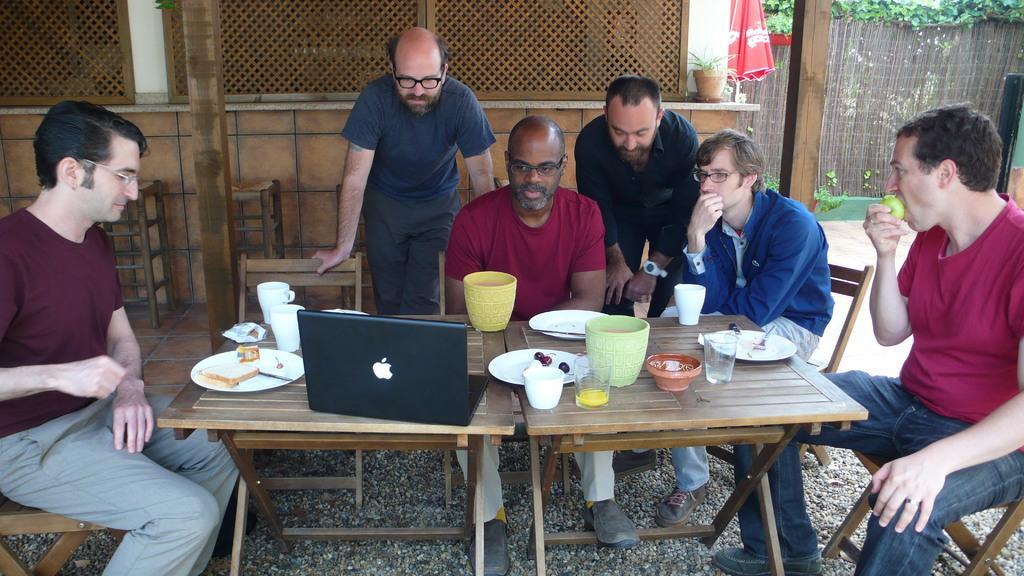Please provide a concise description of this image. There is a man. He is sitting on a chair. He is wearing glass. There is a table in front of him , and there is another table. There are few other persons. One person is standing over here. There are cups, laptop ,plates , there is some food , there is bread. This person is eating fruit. It seems they are watching something , they all are watching something. There is an umbrella ,there is a wall, there is some plants. This is looking like a wooden fence. This is the floor. These are the pebbles. 